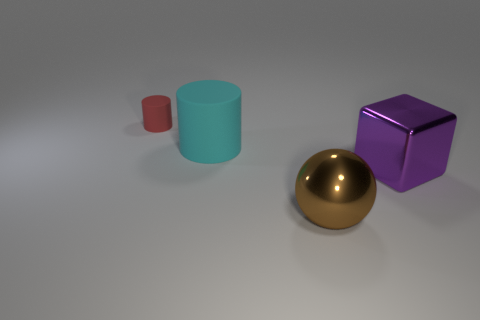What textures can be observed on the surfaces of the objects? The objects in the image have relatively smooth and matte surfaces, with subtle light reflections that indicate they have a non-glossy finish. How do the objects' colors compare in terms of visual warmth or coolness? The red object provides a sense of visual warmth, while the cyan and purple objects convey a cooler visual sensation due to their placement on the color spectrum. 